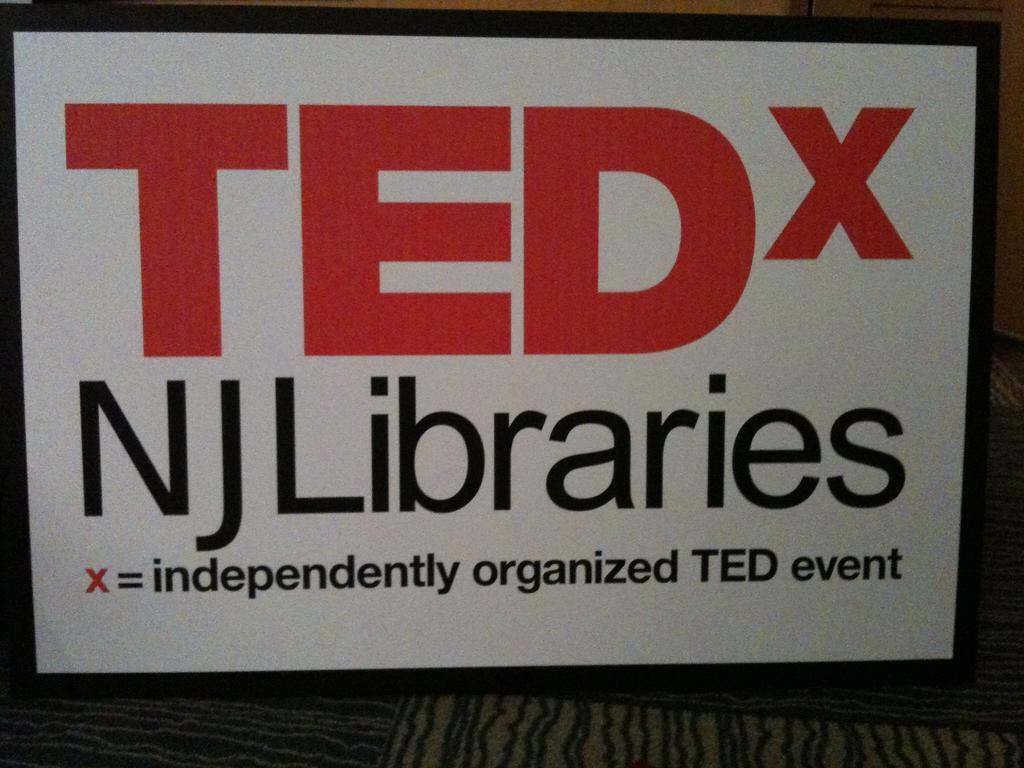<image>
Summarize the visual content of the image. A sign for TEDx events at NJ Libraries. 